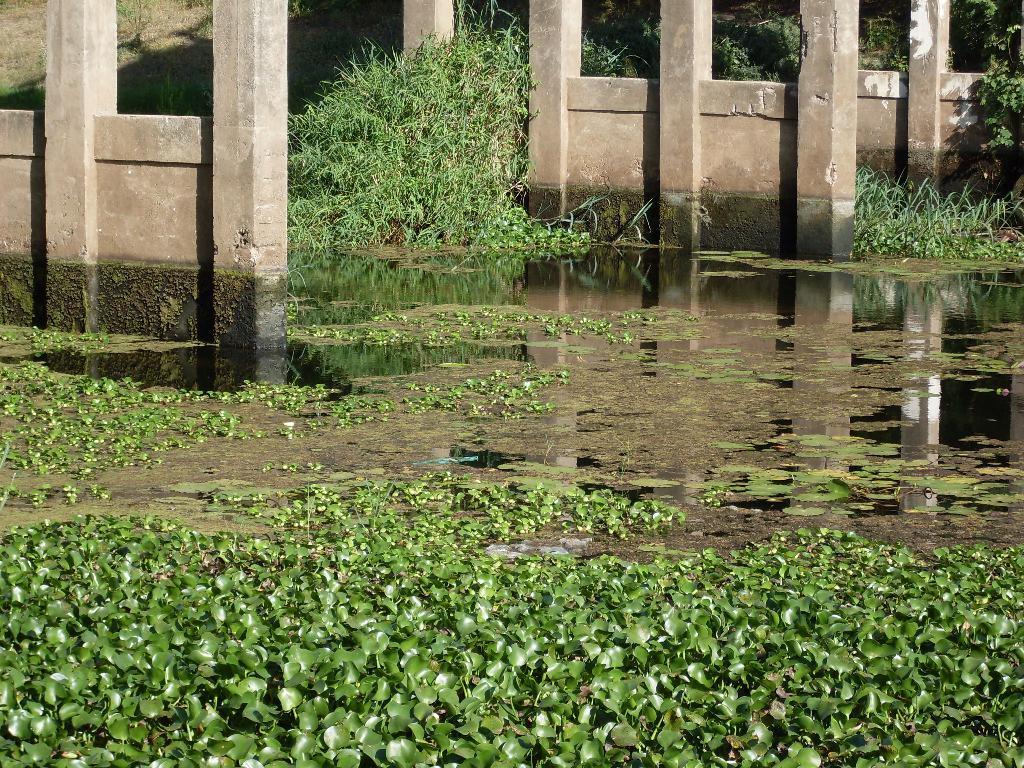Please provide a concise description of this image. There are lotus plants and other plants in the water, near pillars. In the background, there is a grass and plants on the ground. 